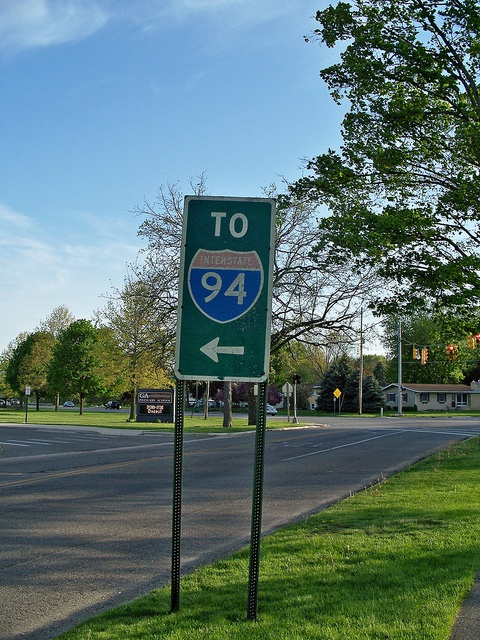Describe the objects in this image and their specific colors. I can see traffic light in darkgray, olive, black, tan, and gray tones, car in darkgray, black, gray, and blue tones, traffic light in darkgray and olive tones, traffic light in darkgray, black, olive, and maroon tones, and car in darkgray, black, and gray tones in this image. 